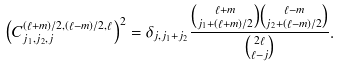Convert formula to latex. <formula><loc_0><loc_0><loc_500><loc_500>\left ( C ^ { ( \ell + m ) / 2 , ( \ell - m ) / 2 , \ell } _ { j _ { 1 } , j _ { 2 } , j } \right ) ^ { 2 } = \delta _ { j , j _ { 1 } + j _ { 2 } } \frac { \binom { \ell + m } { j _ { 1 } + ( \ell + m ) / 2 } \binom { \ell - m } { j _ { 2 } + ( \ell - m ) / 2 } } { \binom { 2 \ell } { \ell - j } } .</formula> 